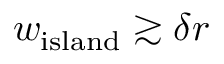<formula> <loc_0><loc_0><loc_500><loc_500>w _ { i s l a n d } \gtrsim \delta r</formula> 